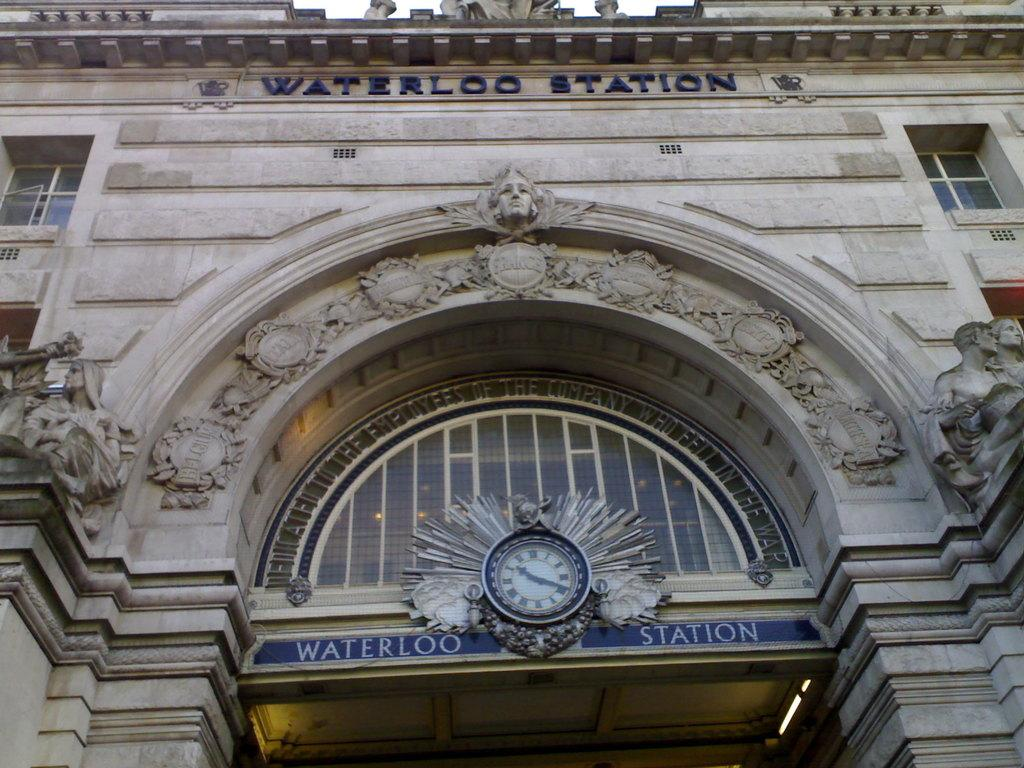<image>
Render a clear and concise summary of the photo. A building front depicting the name Waterloo Station on the front of the building. 